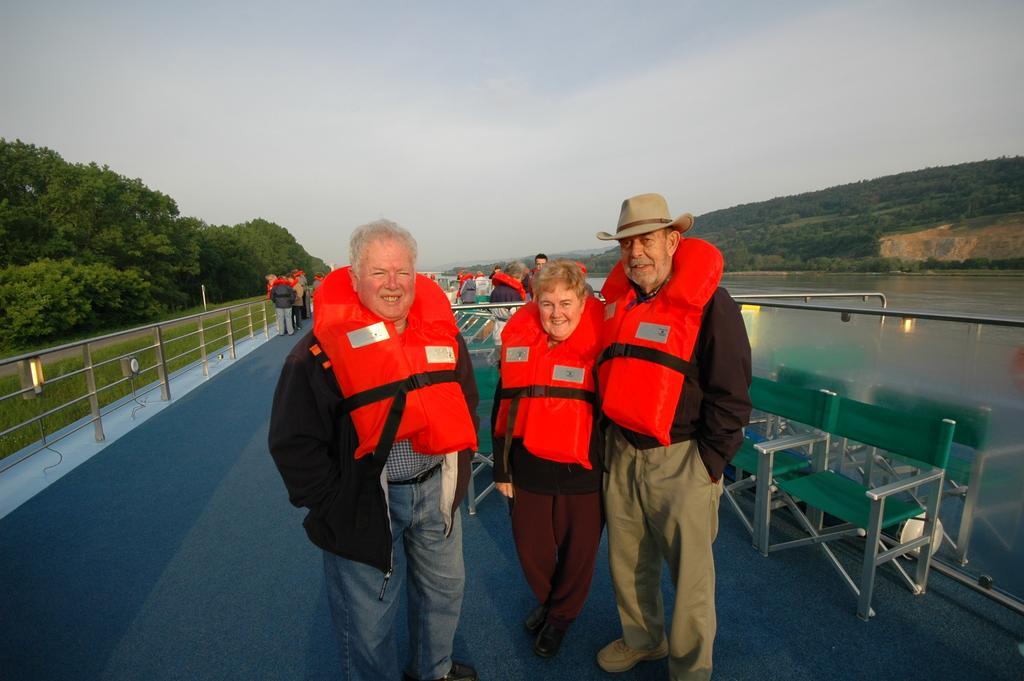Please provide a concise description of this image. In this picture there is a lady and two men in the center of the image, they are wearing jackets and there are other people behind them, it seems to be they are on dock, there are benches on the right side of the image, there are trees and water in the background area of the image. 